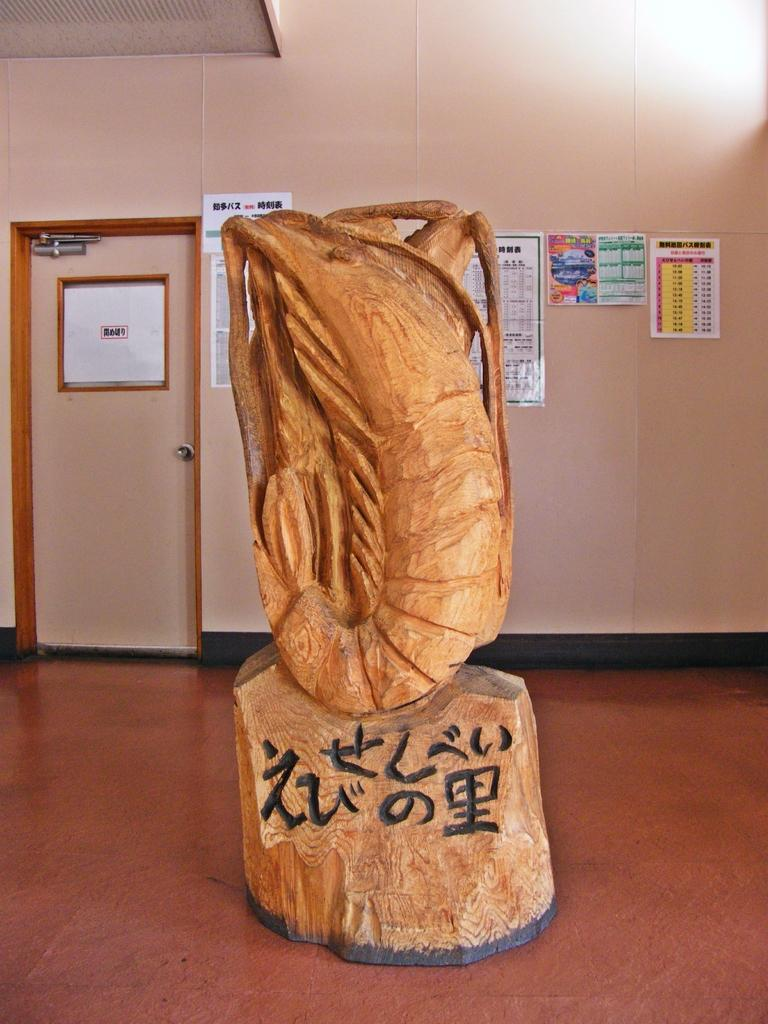<image>
Describe the image concisely. A tan sculpture  on a pedestal engraved "Zu". 